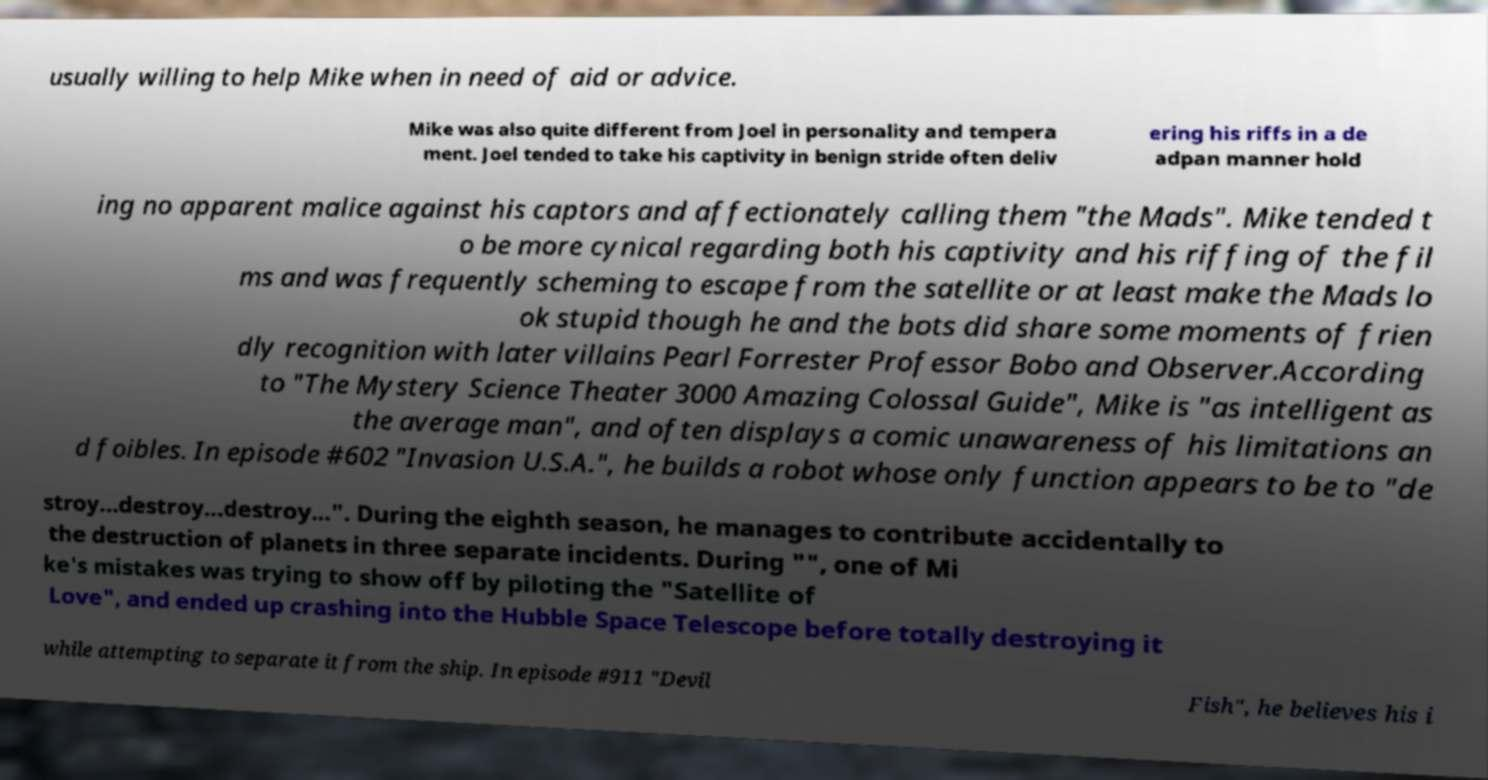There's text embedded in this image that I need extracted. Can you transcribe it verbatim? usually willing to help Mike when in need of aid or advice. Mike was also quite different from Joel in personality and tempera ment. Joel tended to take his captivity in benign stride often deliv ering his riffs in a de adpan manner hold ing no apparent malice against his captors and affectionately calling them "the Mads". Mike tended t o be more cynical regarding both his captivity and his riffing of the fil ms and was frequently scheming to escape from the satellite or at least make the Mads lo ok stupid though he and the bots did share some moments of frien dly recognition with later villains Pearl Forrester Professor Bobo and Observer.According to "The Mystery Science Theater 3000 Amazing Colossal Guide", Mike is "as intelligent as the average man", and often displays a comic unawareness of his limitations an d foibles. In episode #602 "Invasion U.S.A.", he builds a robot whose only function appears to be to "de stroy...destroy...destroy...". During the eighth season, he manages to contribute accidentally to the destruction of planets in three separate incidents. During "", one of Mi ke's mistakes was trying to show off by piloting the "Satellite of Love", and ended up crashing into the Hubble Space Telescope before totally destroying it while attempting to separate it from the ship. In episode #911 "Devil Fish", he believes his i 